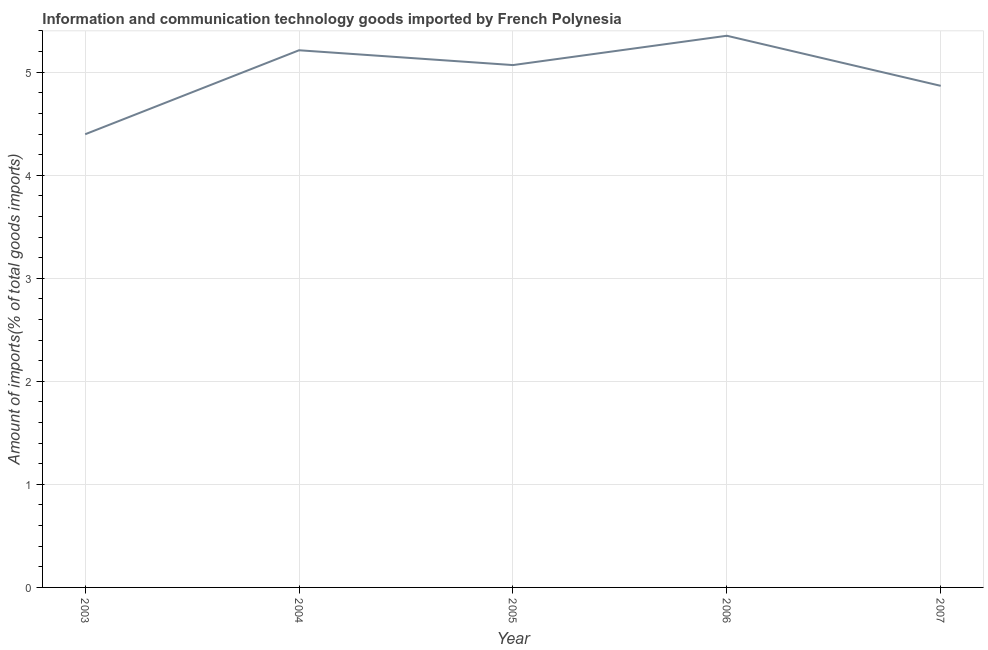What is the amount of ict goods imports in 2006?
Offer a very short reply. 5.35. Across all years, what is the maximum amount of ict goods imports?
Offer a terse response. 5.35. Across all years, what is the minimum amount of ict goods imports?
Your answer should be compact. 4.4. In which year was the amount of ict goods imports maximum?
Give a very brief answer. 2006. What is the sum of the amount of ict goods imports?
Offer a terse response. 24.9. What is the difference between the amount of ict goods imports in 2003 and 2007?
Provide a succinct answer. -0.47. What is the average amount of ict goods imports per year?
Make the answer very short. 4.98. What is the median amount of ict goods imports?
Provide a short and direct response. 5.07. In how many years, is the amount of ict goods imports greater than 2.2 %?
Offer a terse response. 5. What is the ratio of the amount of ict goods imports in 2003 to that in 2007?
Provide a short and direct response. 0.9. Is the amount of ict goods imports in 2005 less than that in 2006?
Offer a very short reply. Yes. What is the difference between the highest and the second highest amount of ict goods imports?
Offer a very short reply. 0.14. What is the difference between the highest and the lowest amount of ict goods imports?
Offer a terse response. 0.96. How many years are there in the graph?
Offer a very short reply. 5. What is the difference between two consecutive major ticks on the Y-axis?
Your answer should be compact. 1. What is the title of the graph?
Your answer should be very brief. Information and communication technology goods imported by French Polynesia. What is the label or title of the X-axis?
Ensure brevity in your answer.  Year. What is the label or title of the Y-axis?
Make the answer very short. Amount of imports(% of total goods imports). What is the Amount of imports(% of total goods imports) in 2003?
Your answer should be compact. 4.4. What is the Amount of imports(% of total goods imports) of 2004?
Keep it short and to the point. 5.21. What is the Amount of imports(% of total goods imports) of 2005?
Provide a succinct answer. 5.07. What is the Amount of imports(% of total goods imports) in 2006?
Your answer should be very brief. 5.35. What is the Amount of imports(% of total goods imports) of 2007?
Provide a short and direct response. 4.87. What is the difference between the Amount of imports(% of total goods imports) in 2003 and 2004?
Your answer should be very brief. -0.81. What is the difference between the Amount of imports(% of total goods imports) in 2003 and 2005?
Ensure brevity in your answer.  -0.67. What is the difference between the Amount of imports(% of total goods imports) in 2003 and 2006?
Ensure brevity in your answer.  -0.96. What is the difference between the Amount of imports(% of total goods imports) in 2003 and 2007?
Offer a very short reply. -0.47. What is the difference between the Amount of imports(% of total goods imports) in 2004 and 2005?
Make the answer very short. 0.14. What is the difference between the Amount of imports(% of total goods imports) in 2004 and 2006?
Give a very brief answer. -0.14. What is the difference between the Amount of imports(% of total goods imports) in 2004 and 2007?
Your answer should be compact. 0.35. What is the difference between the Amount of imports(% of total goods imports) in 2005 and 2006?
Your response must be concise. -0.28. What is the difference between the Amount of imports(% of total goods imports) in 2005 and 2007?
Your response must be concise. 0.2. What is the difference between the Amount of imports(% of total goods imports) in 2006 and 2007?
Ensure brevity in your answer.  0.49. What is the ratio of the Amount of imports(% of total goods imports) in 2003 to that in 2004?
Ensure brevity in your answer.  0.84. What is the ratio of the Amount of imports(% of total goods imports) in 2003 to that in 2005?
Your answer should be very brief. 0.87. What is the ratio of the Amount of imports(% of total goods imports) in 2003 to that in 2006?
Your answer should be very brief. 0.82. What is the ratio of the Amount of imports(% of total goods imports) in 2003 to that in 2007?
Keep it short and to the point. 0.9. What is the ratio of the Amount of imports(% of total goods imports) in 2004 to that in 2005?
Offer a terse response. 1.03. What is the ratio of the Amount of imports(% of total goods imports) in 2004 to that in 2007?
Offer a very short reply. 1.07. What is the ratio of the Amount of imports(% of total goods imports) in 2005 to that in 2006?
Keep it short and to the point. 0.95. What is the ratio of the Amount of imports(% of total goods imports) in 2005 to that in 2007?
Provide a succinct answer. 1.04. 